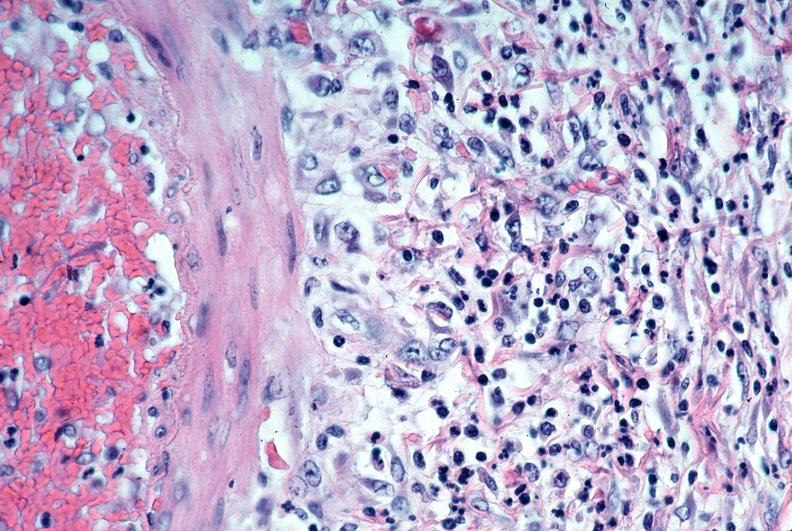what is present?
Answer the question using a single word or phrase. Vasculature 